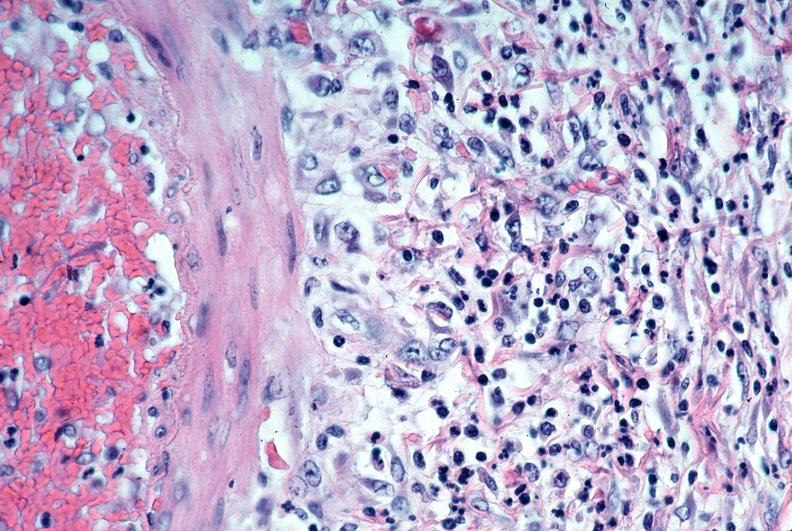what is present?
Answer the question using a single word or phrase. Vasculature 